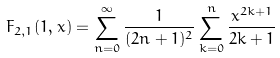Convert formula to latex. <formula><loc_0><loc_0><loc_500><loc_500>\ F _ { 2 , 1 } ( 1 , x ) = \sum _ { n = 0 } ^ { \infty } \frac { 1 } { ( 2 n + 1 ) ^ { 2 } } \sum _ { k = 0 } ^ { n } \frac { x ^ { 2 k + 1 } } { 2 k + 1 }</formula> 